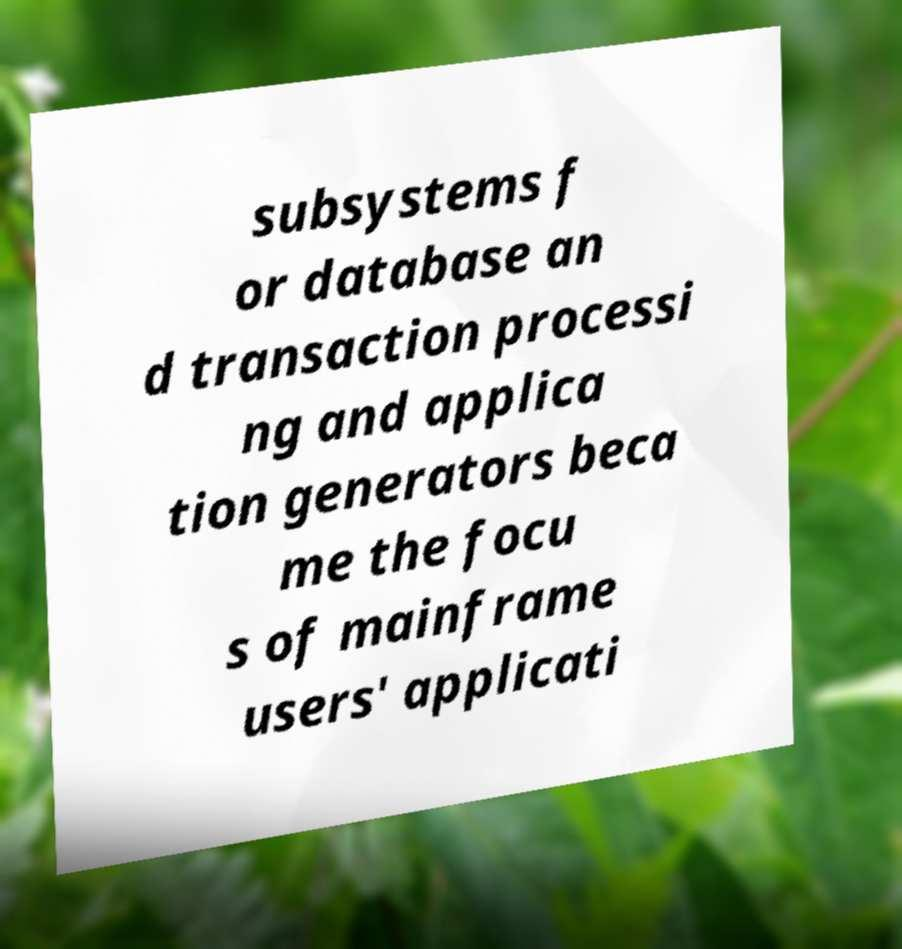Can you accurately transcribe the text from the provided image for me? subsystems f or database an d transaction processi ng and applica tion generators beca me the focu s of mainframe users' applicati 